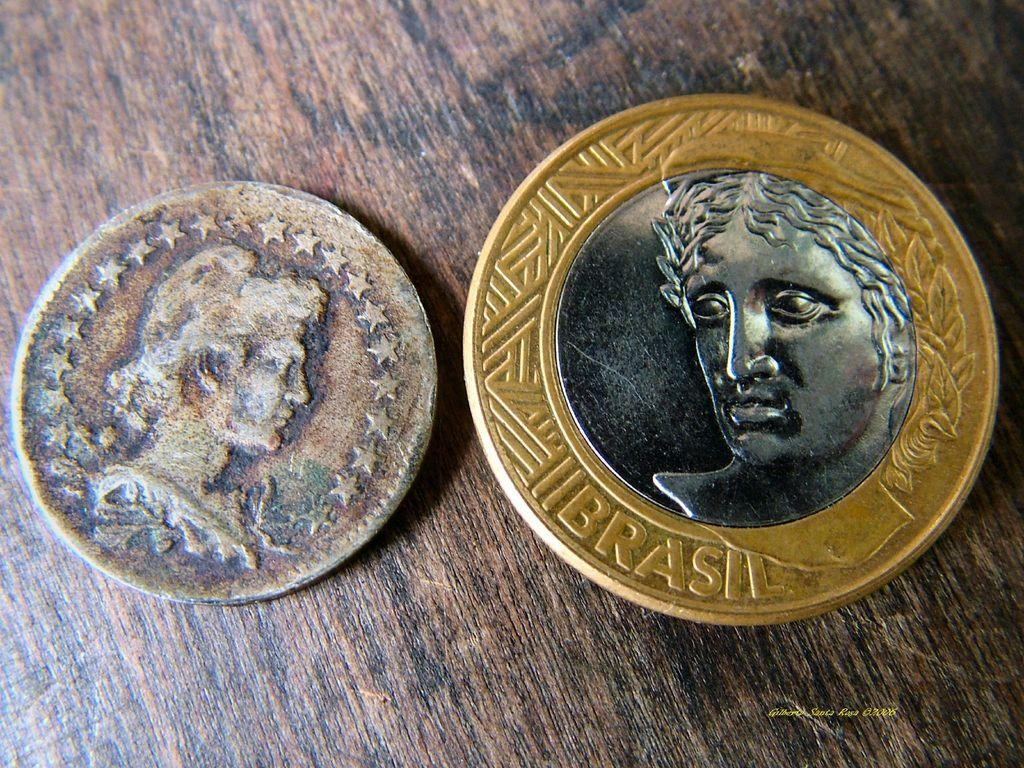<image>
Present a compact description of the photo's key features. a couple of coins next to each other with one labeled 'brasil' 